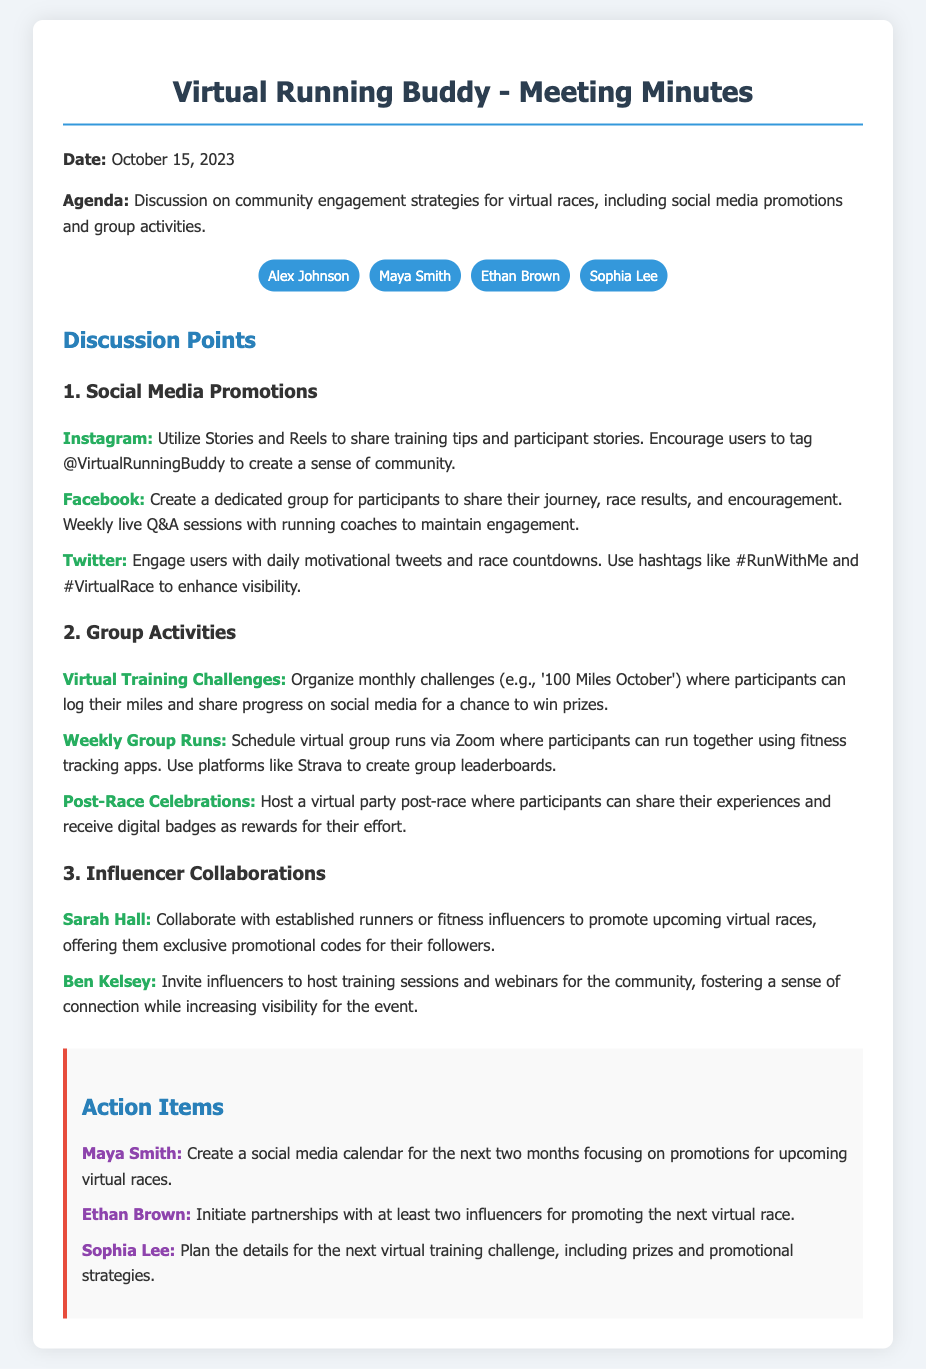What is the date of the meeting? The date of the meeting is specifically mentioned at the beginning of the document.
Answer: October 15, 2023 Who is responsible for creating a social media calendar? The action items section lists the responsible persons for each task, identifying Maya Smith for this task.
Answer: Maya Smith Which platform is suggested for weekly live Q&A sessions? The social media promotions section details suggested activities for different platforms, highlighting Facebook for live Q&A sessions.
Answer: Facebook What is one of the virtual training challenges mentioned? The group activities section provides examples of challenges, specifically noting '100 Miles October.'
Answer: 100 Miles October Who is one of the influencers mentioned for collaboration? The influencer collaborations section names individuals for potential partnership, specifically Sarah Hall.
Answer: Sarah Hall How many participants were listed in the meeting? The participants section lists the individuals who attended the meeting, counting them to establish the total.
Answer: Four What type of post-race event is planned? The group activities section describes an event that occurs after races, specifically detailing the virtual party.
Answer: Virtual party Which app is suggested for virtual group runs? The group activities section mentions a specific app where participants can engage in virtual runs, identifying Strava.
Answer: Strava 